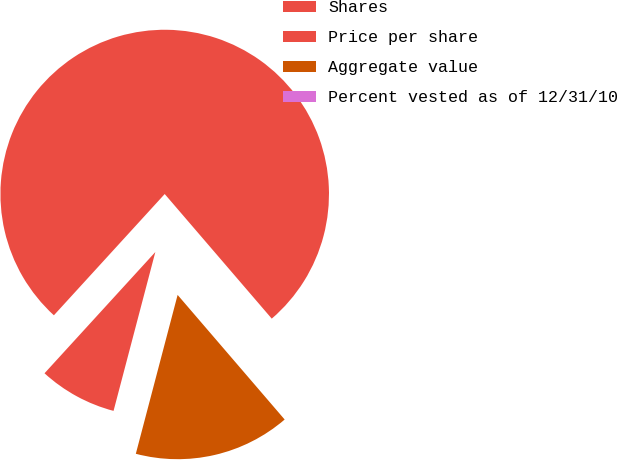Convert chart. <chart><loc_0><loc_0><loc_500><loc_500><pie_chart><fcel>Shares<fcel>Price per share<fcel>Aggregate value<fcel>Percent vested as of 12/31/10<nl><fcel>76.92%<fcel>7.69%<fcel>15.39%<fcel>0.0%<nl></chart> 